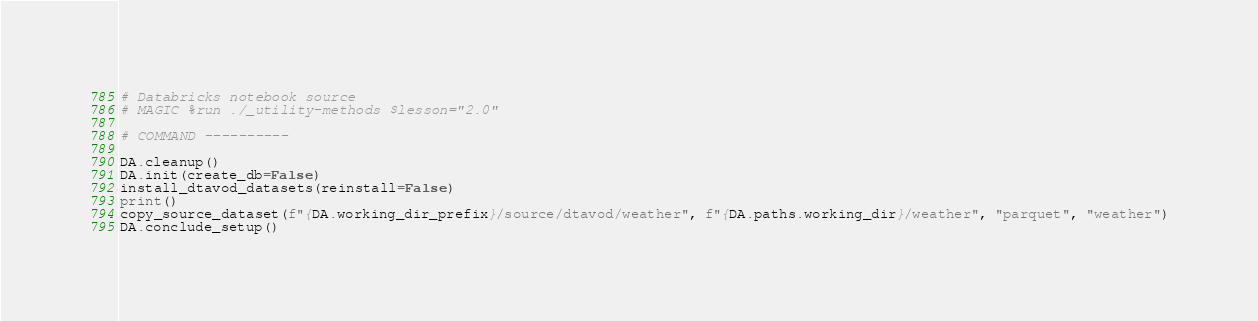Convert code to text. <code><loc_0><loc_0><loc_500><loc_500><_Python_># Databricks notebook source
# MAGIC %run ./_utility-methods $lesson="2.0"

# COMMAND ----------

DA.cleanup()
DA.init(create_db=False)
install_dtavod_datasets(reinstall=False)
print()
copy_source_dataset(f"{DA.working_dir_prefix}/source/dtavod/weather", f"{DA.paths.working_dir}/weather", "parquet", "weather")
DA.conclude_setup()
</code> 